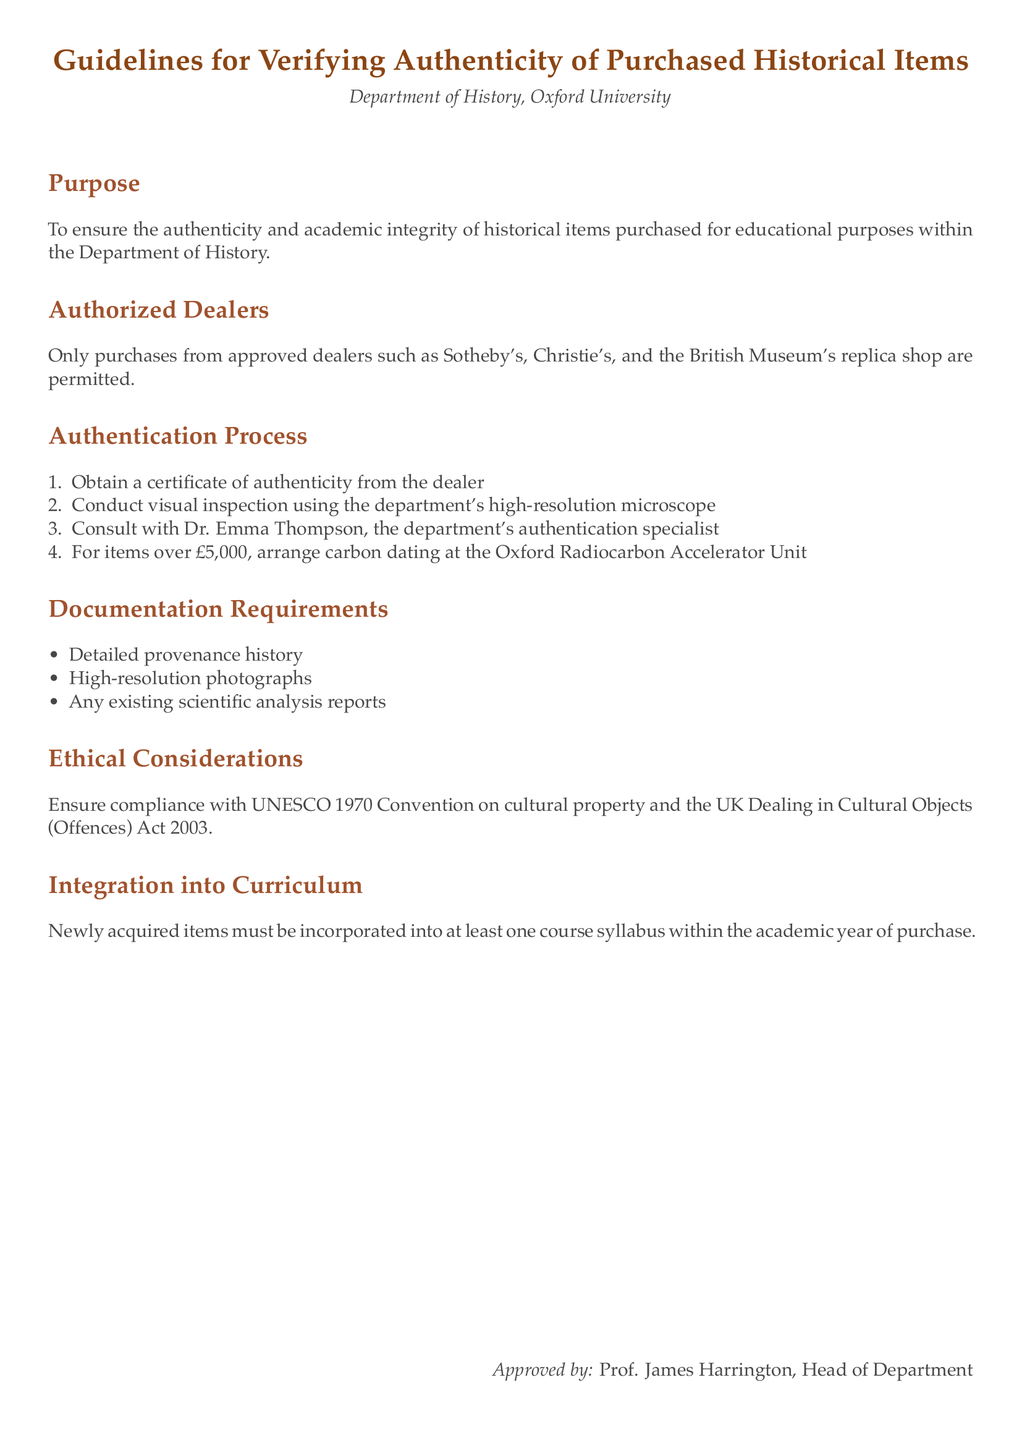What is the main purpose of the guidelines? The guidelines aim to ensure the authenticity and academic integrity of historical items purchased for educational purposes within the Department of History.
Answer: Ensuring authenticity and academic integrity Who are the authorized dealers mentioned? The document lists that only purchases from approved dealers such as Sotheby's, Christie's, and the British Museum's replica shop are permitted.
Answer: Sotheby's, Christie's, and the British Museum's replica shop What is the first step in the authentication process? The first step in the authentication process outlined in the document is to obtain a certificate of authenticity from the dealer.
Answer: Obtain a certificate of authenticity What is required for items over £5,000? The guidelines state that for items over £5,000, it is necessary to arrange carbon dating at the Oxford Radiocarbon Accelerator Unit.
Answer: Arrange carbon dating What must be included in documentation requirements? Documentation requirements include detailed provenance history, high-resolution photographs, and any existing scientific analysis reports.
Answer: Detailed provenance history, high-resolution photographs, and scientific analysis reports Which convention should be complied with according to ethical considerations? The guidelines indicate that compliance with the UNESCO 1970 Convention on cultural property is required.
Answer: UNESCO 1970 Convention How often must newly acquired items be incorporated into the curriculum? The document specifies that newly acquired items must be incorporated into at least one course syllabus within the academic year of purchase.
Answer: At least one course syllabus within the academic year Who approved these guidelines? The guidelines were approved by Prof. James Harrington, the Head of Department, as indicated at the end of the document.
Answer: Prof. James Harrington 